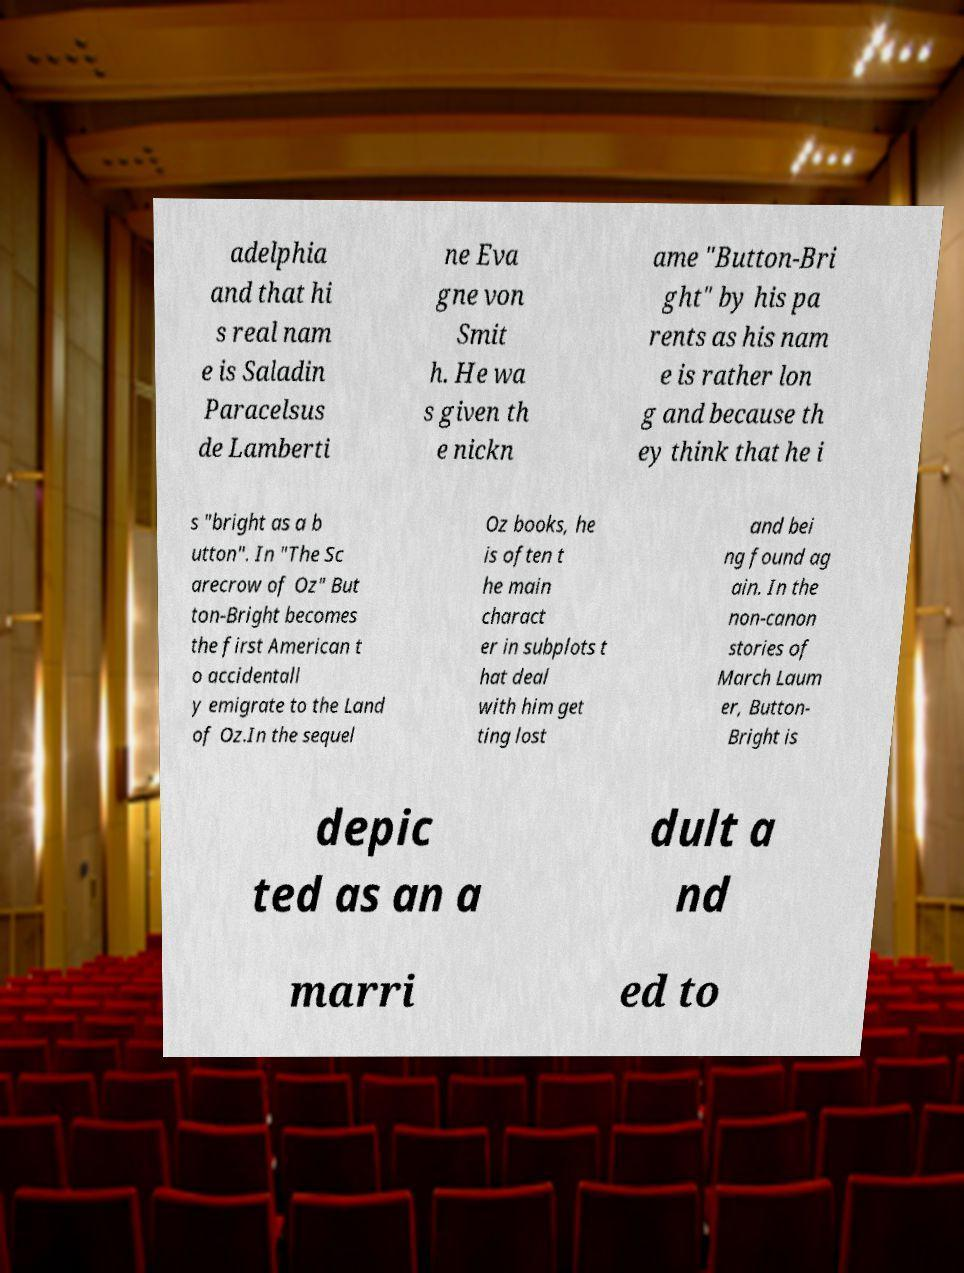Could you extract and type out the text from this image? adelphia and that hi s real nam e is Saladin Paracelsus de Lamberti ne Eva gne von Smit h. He wa s given th e nickn ame "Button-Bri ght" by his pa rents as his nam e is rather lon g and because th ey think that he i s "bright as a b utton". In "The Sc arecrow of Oz" But ton-Bright becomes the first American t o accidentall y emigrate to the Land of Oz.In the sequel Oz books, he is often t he main charact er in subplots t hat deal with him get ting lost and bei ng found ag ain. In the non-canon stories of March Laum er, Button- Bright is depic ted as an a dult a nd marri ed to 